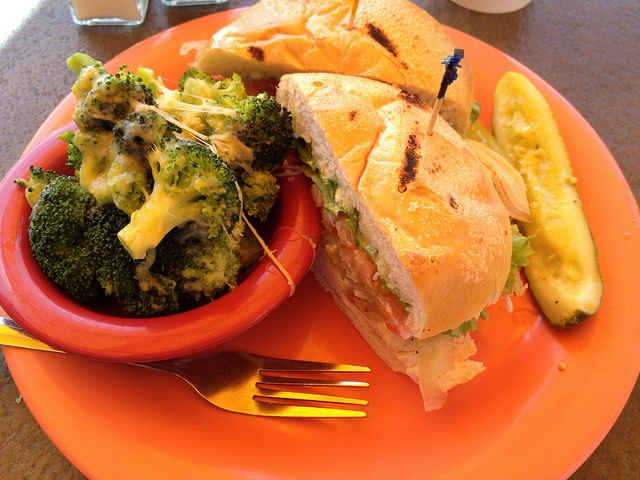Describe the objects in this image and their specific colors. I can see dining table in red, orange, maroon, and brown tones, sandwich in white, orange, red, and brown tones, bowl in white, red, brown, and salmon tones, sandwich in white, orange, tan, and brown tones, and broccoli in white, black, olive, and maroon tones in this image. 